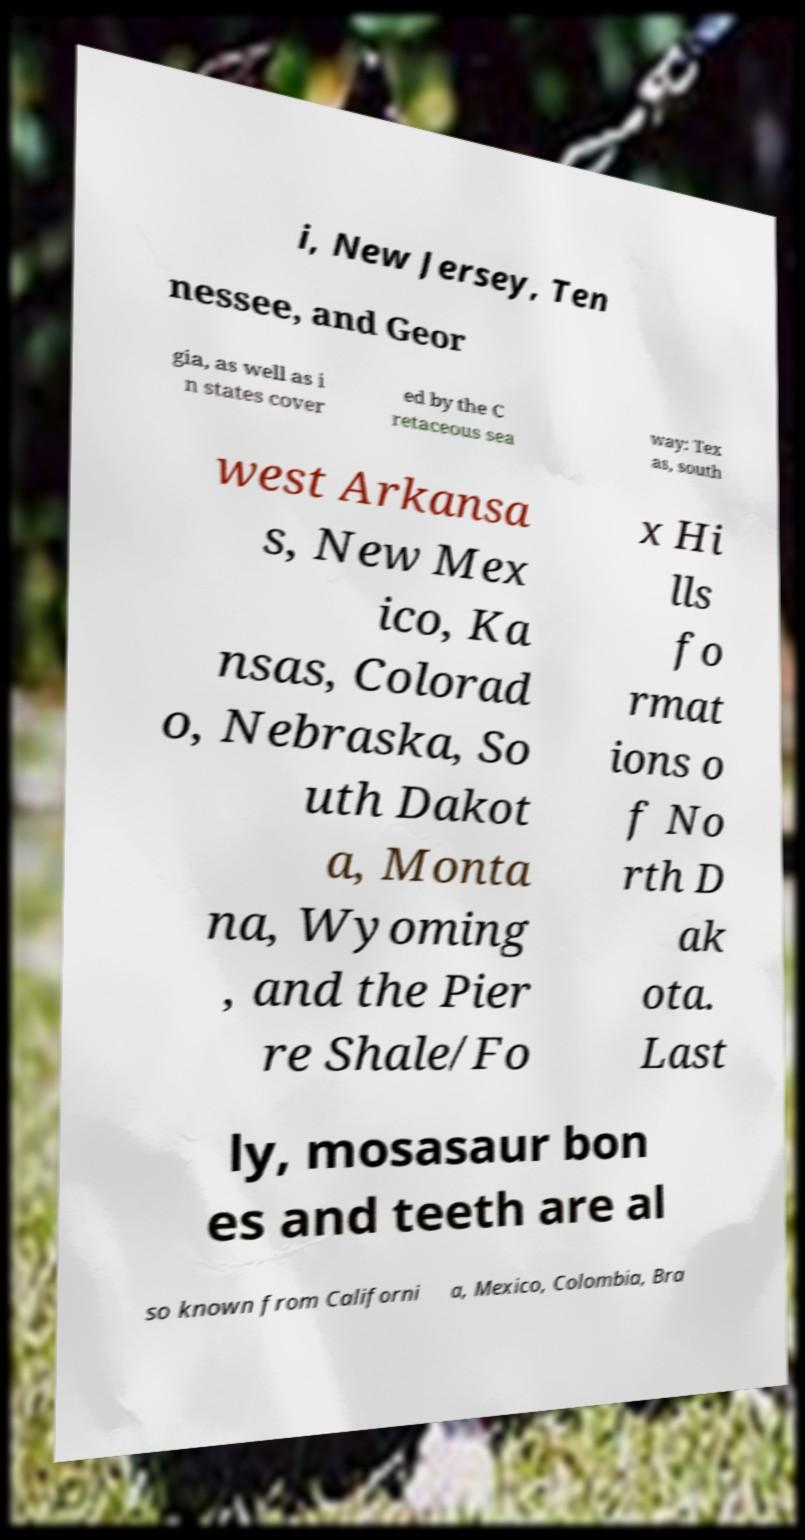Can you read and provide the text displayed in the image?This photo seems to have some interesting text. Can you extract and type it out for me? i, New Jersey, Ten nessee, and Geor gia, as well as i n states cover ed by the C retaceous sea way: Tex as, south west Arkansa s, New Mex ico, Ka nsas, Colorad o, Nebraska, So uth Dakot a, Monta na, Wyoming , and the Pier re Shale/Fo x Hi lls fo rmat ions o f No rth D ak ota. Last ly, mosasaur bon es and teeth are al so known from Californi a, Mexico, Colombia, Bra 